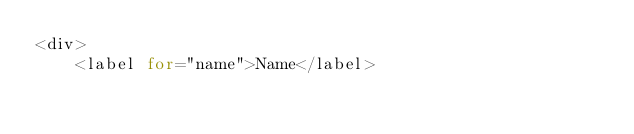<code> <loc_0><loc_0><loc_500><loc_500><_PHP_><div>
    <label for="name">Name</label></code> 